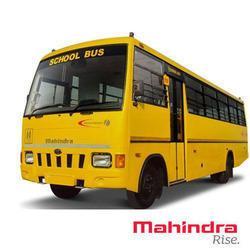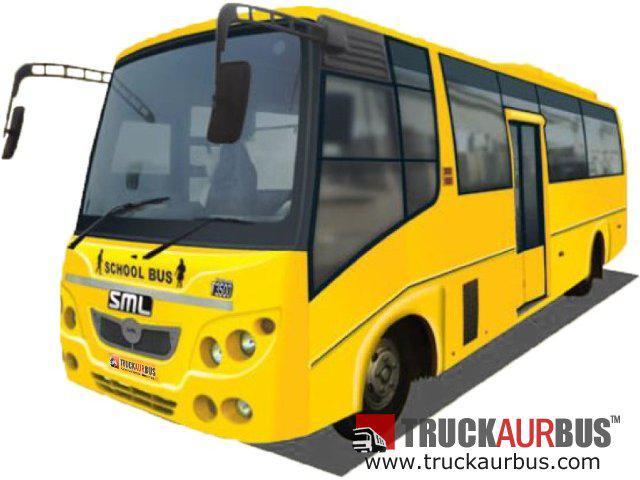The first image is the image on the left, the second image is the image on the right. For the images shown, is this caption "The left and right image contains the same number of buses with one facing right forward and the other facing left forward." true? Answer yes or no. No. The first image is the image on the left, the second image is the image on the right. Evaluate the accuracy of this statement regarding the images: "Each image shows the front of a flat-fronted bus, and the buses depicted on the left and right are angled in opposite directions.". Is it true? Answer yes or no. No. 